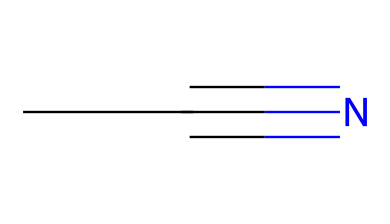What is the total number of carbon atoms in acetonitrile? The SMILES representation shows "CC," indicating there are two carbon atoms.
Answer: 2 What is the functional group present in acetonitrile? The presence of "C#N" in the SMILES indicates a cyano group, which is characteristic of nitriles.
Answer: cyano group How many hydrogen atoms are in acetonitrile? Each carbon in the "CC" structure can bond with three hydrogen atoms in a typical alkane structure, but due to the triple bond with nitrogen, this reduces the total number of hydrogens to six.
Answer: 6 What type of bond is present between the carbon and nitrogen in acetonitrile? The "C#N" notation indicates a triple bond, which is a defining feature of nitriles.
Answer: triple bond What is the hybridization of the carbon atom in the cyano group of acetonitrile? The carbon in the cyano group is involved in a triple bond with nitrogen, indicating it is sp hybridized.
Answer: sp Does acetonitrile have a polar or nonpolar nature? The presence of the electronegative nitrogen and the structure creates a dipole moment, indicating that acetonitrile is polar.
Answer: polar What is the main use of acetonitrile in special effects makeup? In special effects makeup, acetonitrile is commonly used as a solvent due to its ability to dissolve a wide range of substances.
Answer: solvent 